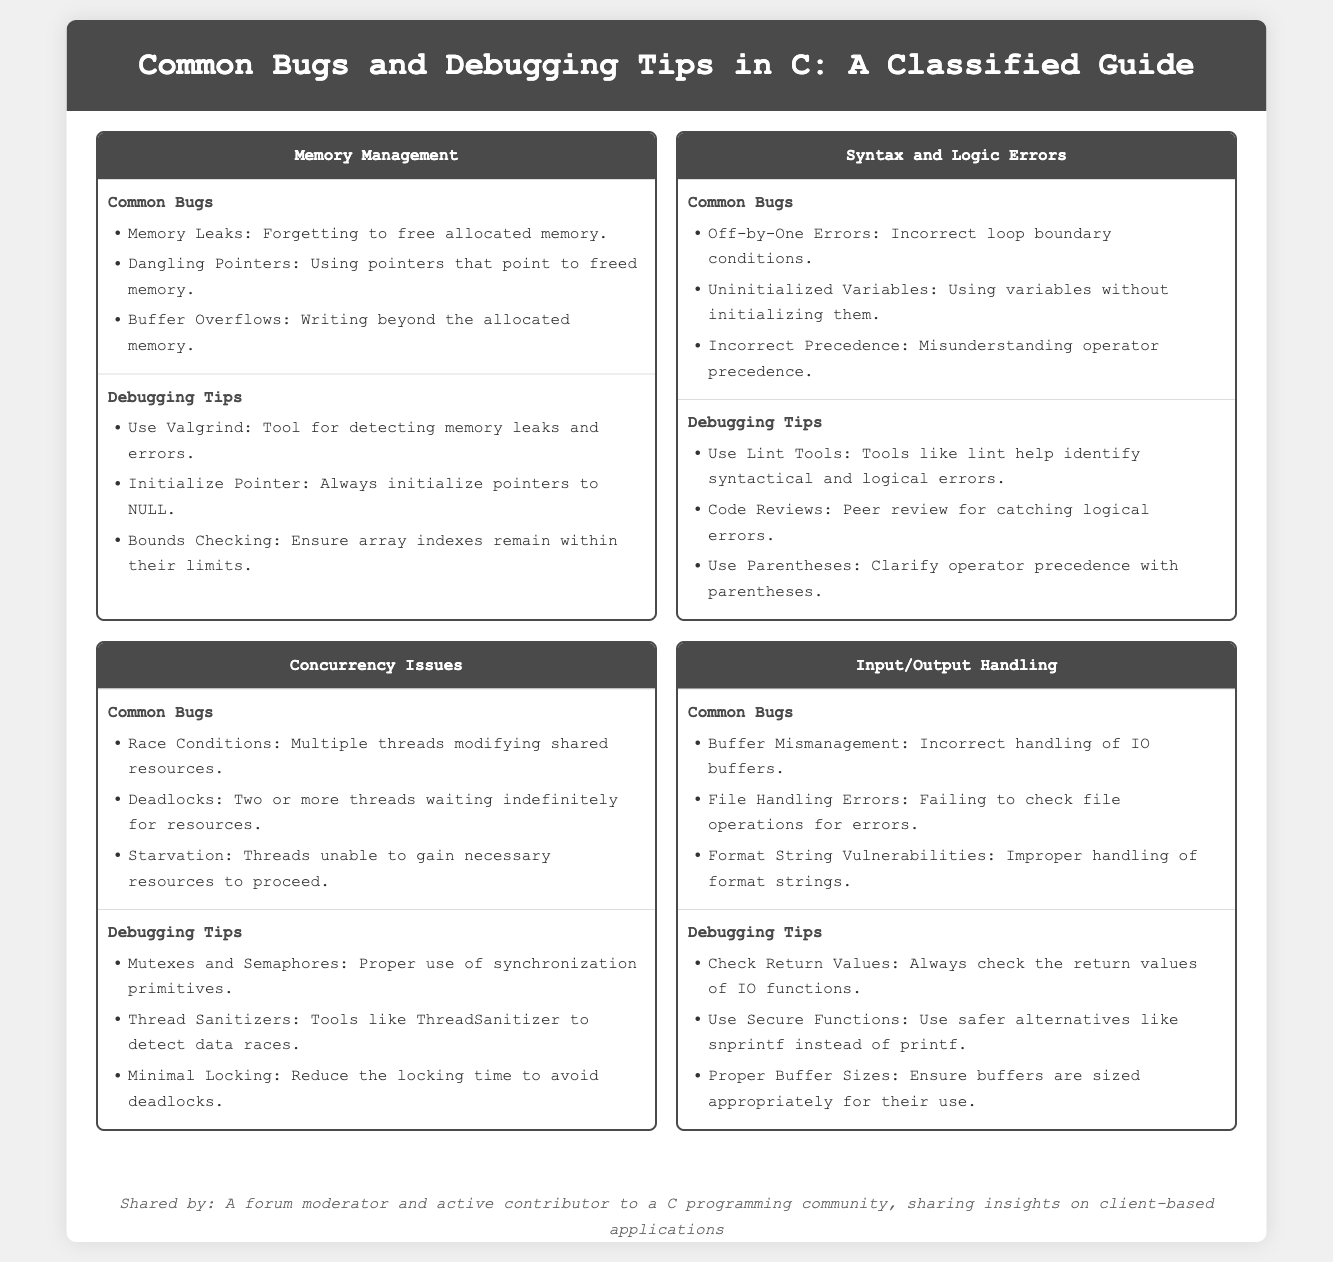What are the common bugs related to memory management? The common bugs listed under memory management include memory leaks, dangling pointers, and buffer overflows.
Answer: Memory leaks, dangling pointers, buffer overflows What tool is recommended for detecting memory leaks? The document recommends using Valgrind as a tool for detecting memory leaks and errors.
Answer: Valgrind What is a prevalent concurrency issue mentioned? The infographic lists race conditions as one of the common bugs in concurrency issues.
Answer: Race conditions What debugging tip helps with syntax and logic errors? The document suggests using lint tools to help identify syntactical and logical errors.
Answer: Use lint tools What should be checked when handling input/output? The document emphasizes the importance of checking return values of IO functions.
Answer: Check return values What is one tool to detect data races in concurrency? The graphic mentions using ThreadSanitizer as a tool to detect data races.
Answer: ThreadSanitizer What type of error involves writing beyond allocated memory? The document categorizes buffer overflows as an error related to writing beyond allocated memory.
Answer: Buffer Overflows How many common bugs are listed under input/output handling? The infographic lists three common bugs related to input/output handling.
Answer: Three 